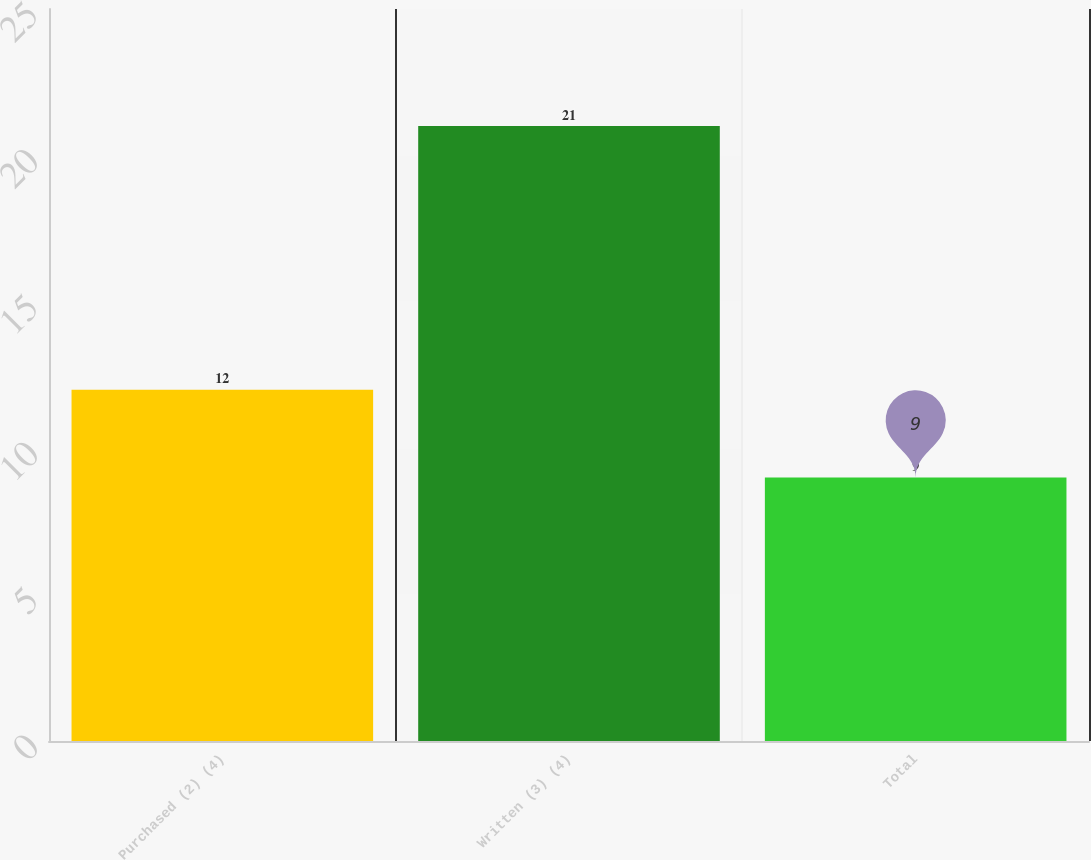<chart> <loc_0><loc_0><loc_500><loc_500><bar_chart><fcel>Purchased (2) (4)<fcel>Written (3) (4)<fcel>Total<nl><fcel>12<fcel>21<fcel>9<nl></chart> 